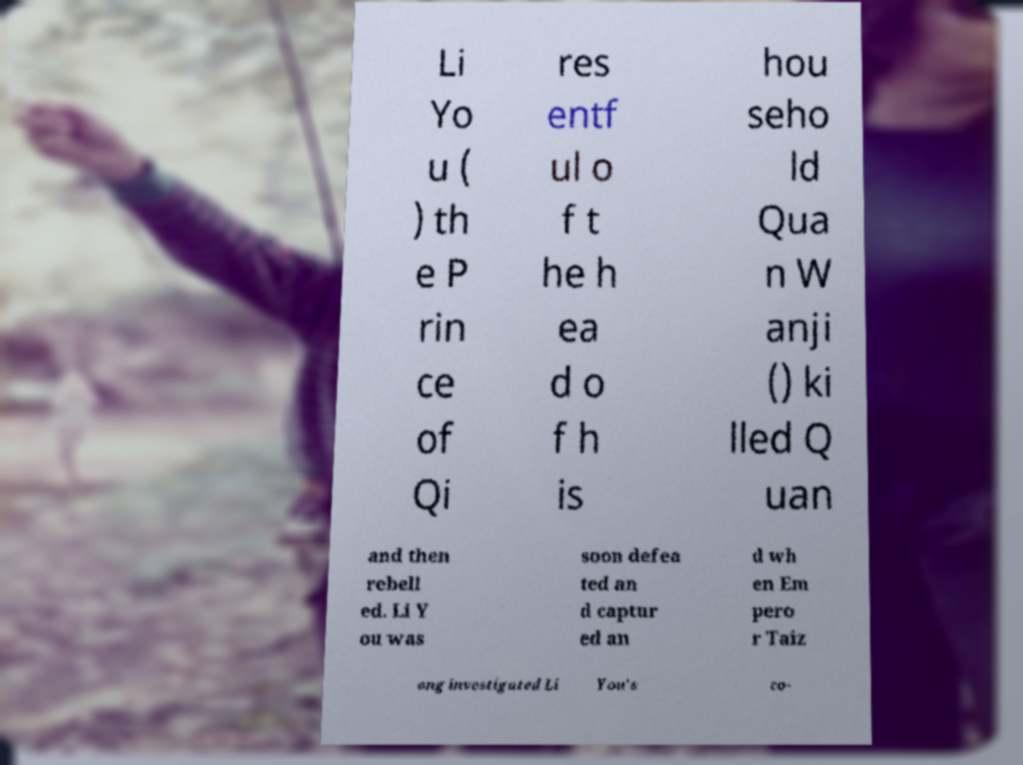Please read and relay the text visible in this image. What does it say? Li Yo u ( ) th e P rin ce of Qi res entf ul o f t he h ea d o f h is hou seho ld Qua n W anji () ki lled Q uan and then rebell ed. Li Y ou was soon defea ted an d captur ed an d wh en Em pero r Taiz ong investigated Li You's co- 